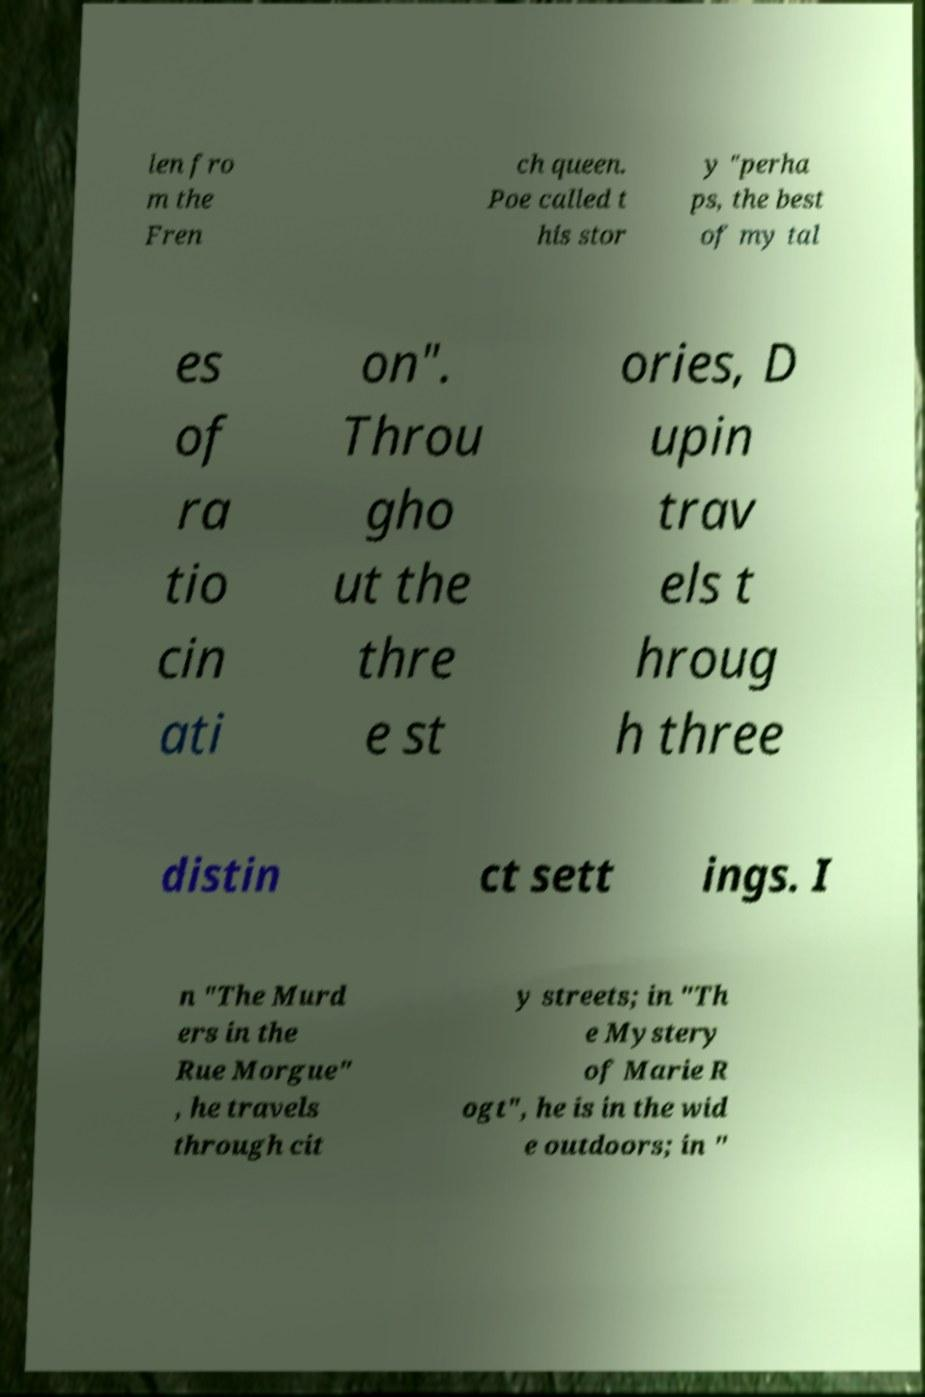What messages or text are displayed in this image? I need them in a readable, typed format. len fro m the Fren ch queen. Poe called t his stor y "perha ps, the best of my tal es of ra tio cin ati on". Throu gho ut the thre e st ories, D upin trav els t hroug h three distin ct sett ings. I n "The Murd ers in the Rue Morgue" , he travels through cit y streets; in "Th e Mystery of Marie R ogt", he is in the wid e outdoors; in " 